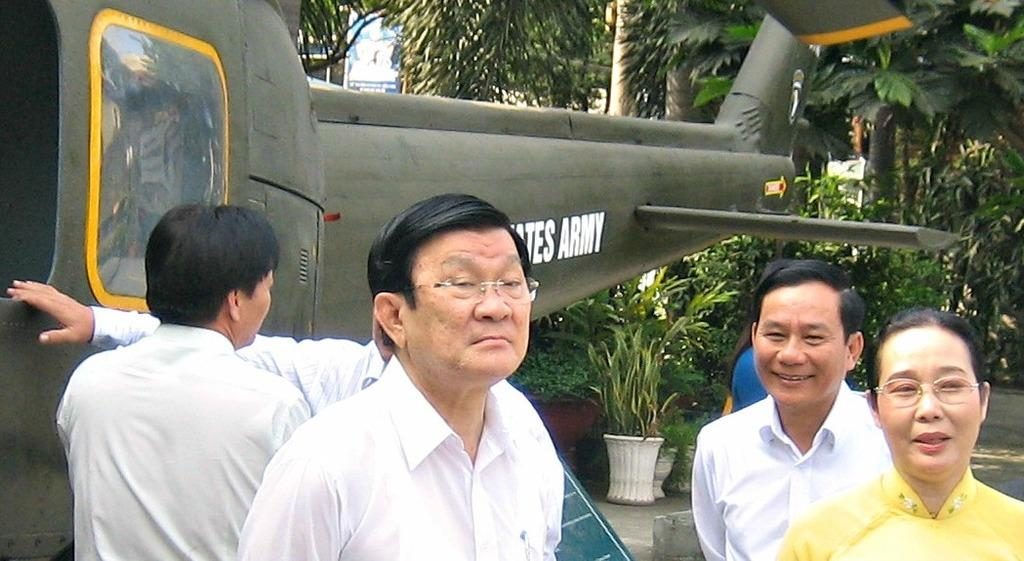<image>
Render a clear and concise summary of the photo. four people stand in front of a United States Army helicopter 